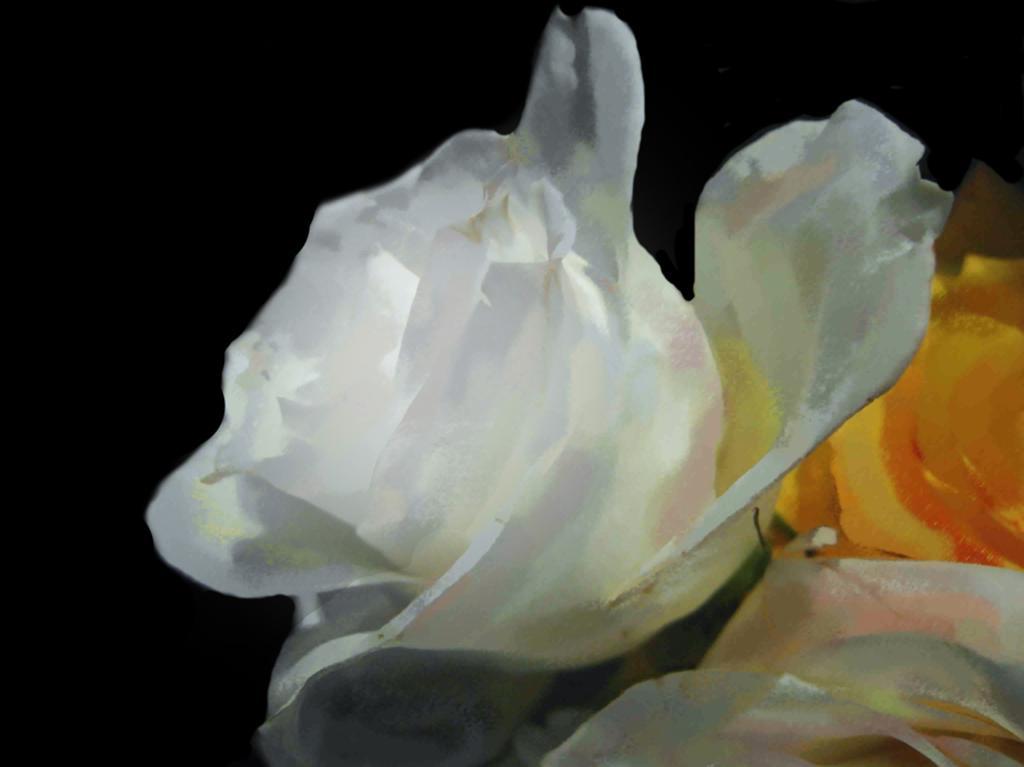Please provide a concise description of this image. In this image I can see the flowers which are in white, yellow and orange color. And there is a black background. 